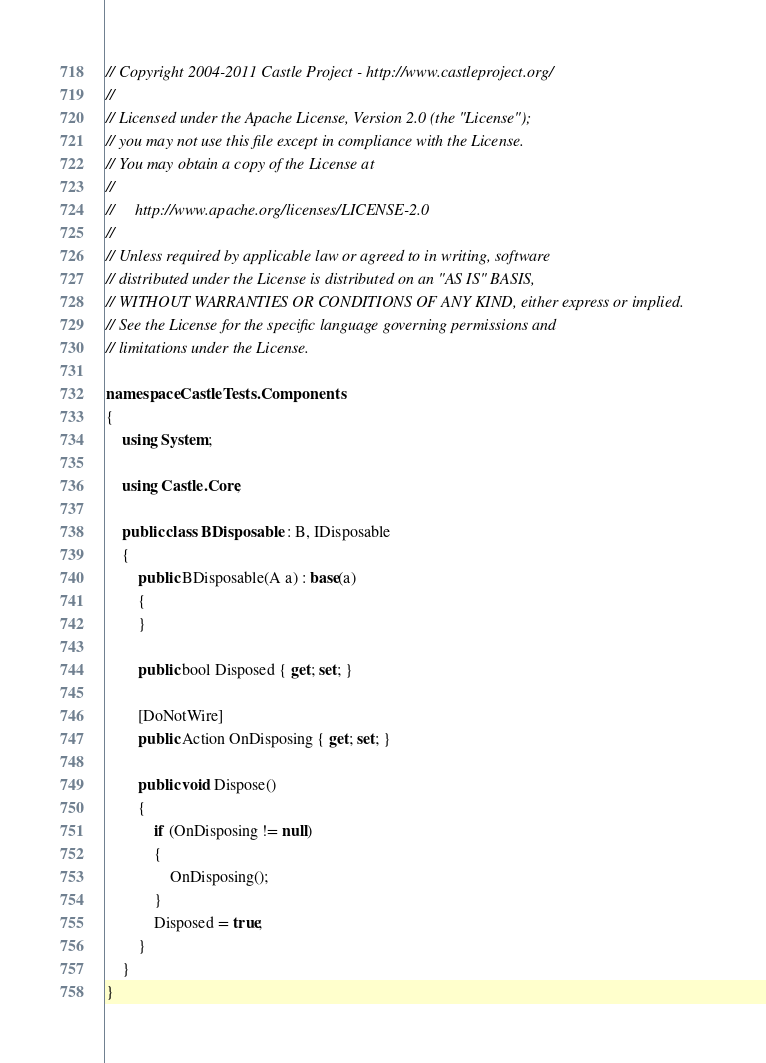Convert code to text. <code><loc_0><loc_0><loc_500><loc_500><_C#_>// Copyright 2004-2011 Castle Project - http://www.castleproject.org/
// 
// Licensed under the Apache License, Version 2.0 (the "License");
// you may not use this file except in compliance with the License.
// You may obtain a copy of the License at
// 
//     http://www.apache.org/licenses/LICENSE-2.0
// 
// Unless required by applicable law or agreed to in writing, software
// distributed under the License is distributed on an "AS IS" BASIS,
// WITHOUT WARRANTIES OR CONDITIONS OF ANY KIND, either express or implied.
// See the License for the specific language governing permissions and
// limitations under the License.

namespace CastleTests.Components
{
	using System;

	using Castle.Core;

	public class BDisposable : B, IDisposable
	{
		public BDisposable(A a) : base(a)
		{
		}

		public bool Disposed { get; set; }

		[DoNotWire]
		public Action OnDisposing { get; set; }

		public void Dispose()
		{
			if (OnDisposing != null)
			{
				OnDisposing();
			}
			Disposed = true;
		}
	}
}</code> 